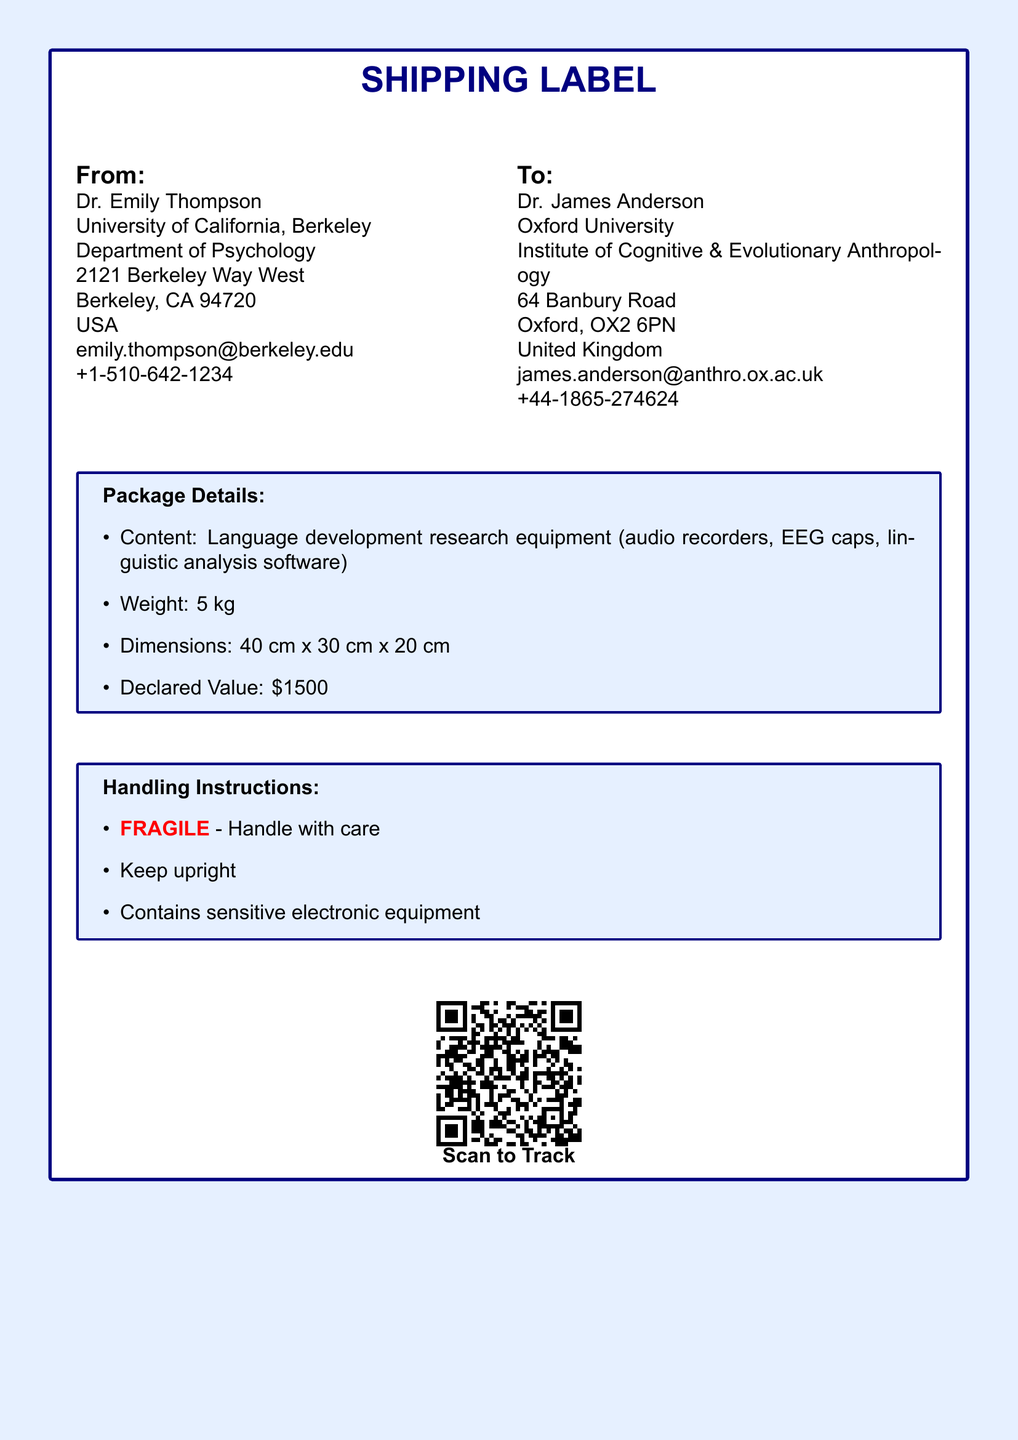What is the sender's name? The sender's name is provided in the "From" section of the document.
Answer: Dr. Emily Thompson What is the recipient's email address? The email address of the recipient is listed under the "To" section.
Answer: james.anderson@anthro.ox.ac.uk What is the declared value of the package? The declared value is specifically mentioned in the package details box.
Answer: $1500 What are the dimensions of the package? The dimensions can be found in the package details section, indicating its size.
Answer: 40 cm x 30 cm x 20 cm Is the package marked as fragile? The handling instructions state specific handling precautions for the package, including its fragility.
Answer: Yes Who is the recipient of the package? The recipient's name is specified in the "To" section of the document.
Answer: Dr. James Anderson How much does the package weigh? The weight of the package is mentioned in the package details.
Answer: 5 kg What type of equipment is contained in the package? The contents of the package are detailed in the package details section.
Answer: Language development research equipment What should be done with the package to prevent damage? The handling instructions outline specific precautions to take with the package.
Answer: Handle with care What is the tracking method for this shipment? The method of tracking is specified at the bottom of the label through a QR code.
Answer: QR code 